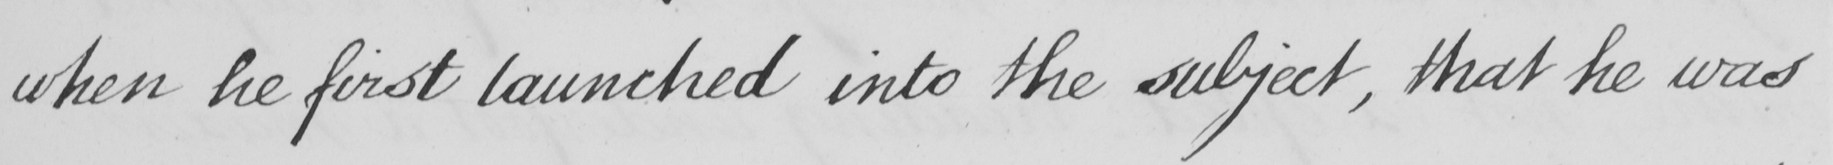What does this handwritten line say? when he first launched into the subject , that he was 